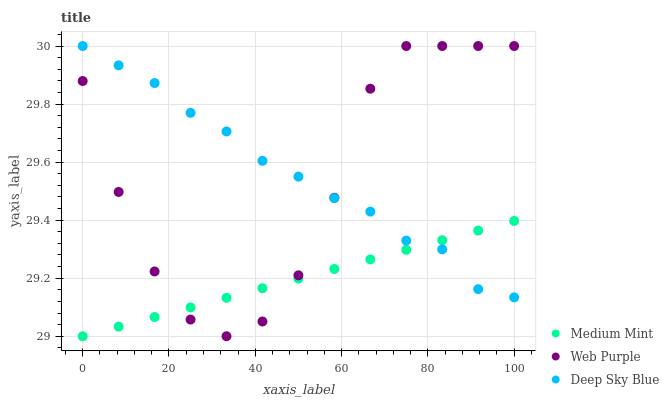Does Medium Mint have the minimum area under the curve?
Answer yes or no. Yes. Does Deep Sky Blue have the maximum area under the curve?
Answer yes or no. Yes. Does Web Purple have the minimum area under the curve?
Answer yes or no. No. Does Web Purple have the maximum area under the curve?
Answer yes or no. No. Is Medium Mint the smoothest?
Answer yes or no. Yes. Is Web Purple the roughest?
Answer yes or no. Yes. Is Deep Sky Blue the smoothest?
Answer yes or no. No. Is Deep Sky Blue the roughest?
Answer yes or no. No. Does Medium Mint have the lowest value?
Answer yes or no. Yes. Does Web Purple have the lowest value?
Answer yes or no. No. Does Deep Sky Blue have the highest value?
Answer yes or no. Yes. Does Medium Mint intersect Deep Sky Blue?
Answer yes or no. Yes. Is Medium Mint less than Deep Sky Blue?
Answer yes or no. No. Is Medium Mint greater than Deep Sky Blue?
Answer yes or no. No. 